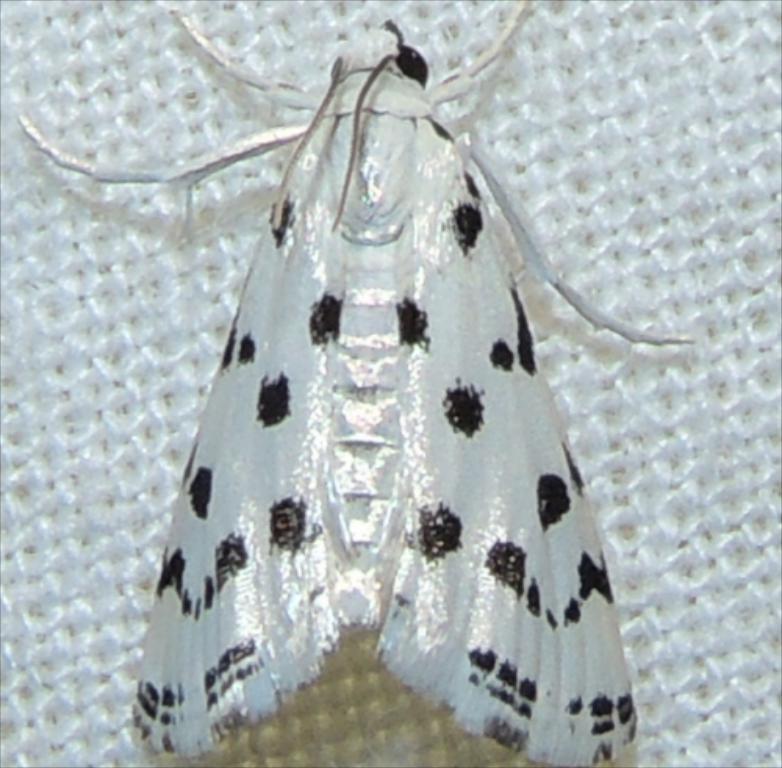How would you summarize this image in a sentence or two? In this picture I can observe an insect which is in white and black color. This insect in on the white color surface. 